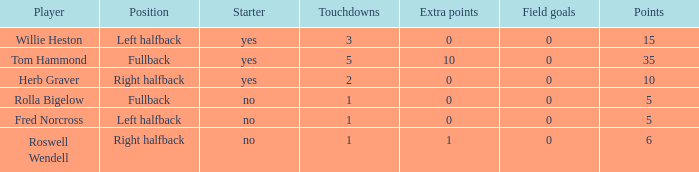Can you parse all the data within this table? {'header': ['Player', 'Position', 'Starter', 'Touchdowns', 'Extra points', 'Field goals', 'Points'], 'rows': [['Willie Heston', 'Left halfback', 'yes', '3', '0', '0', '15'], ['Tom Hammond', 'Fullback', 'yes', '5', '10', '0', '35'], ['Herb Graver', 'Right halfback', 'yes', '2', '0', '0', '10'], ['Rolla Bigelow', 'Fullback', 'no', '1', '0', '0', '5'], ['Fred Norcross', 'Left halfback', 'no', '1', '0', '0', '5'], ['Roswell Wendell', 'Right halfback', 'no', '1', '1', '0', '6']]} What is the lowest number of touchdowns for left halfback WIllie Heston who has more than 15 points? None. 